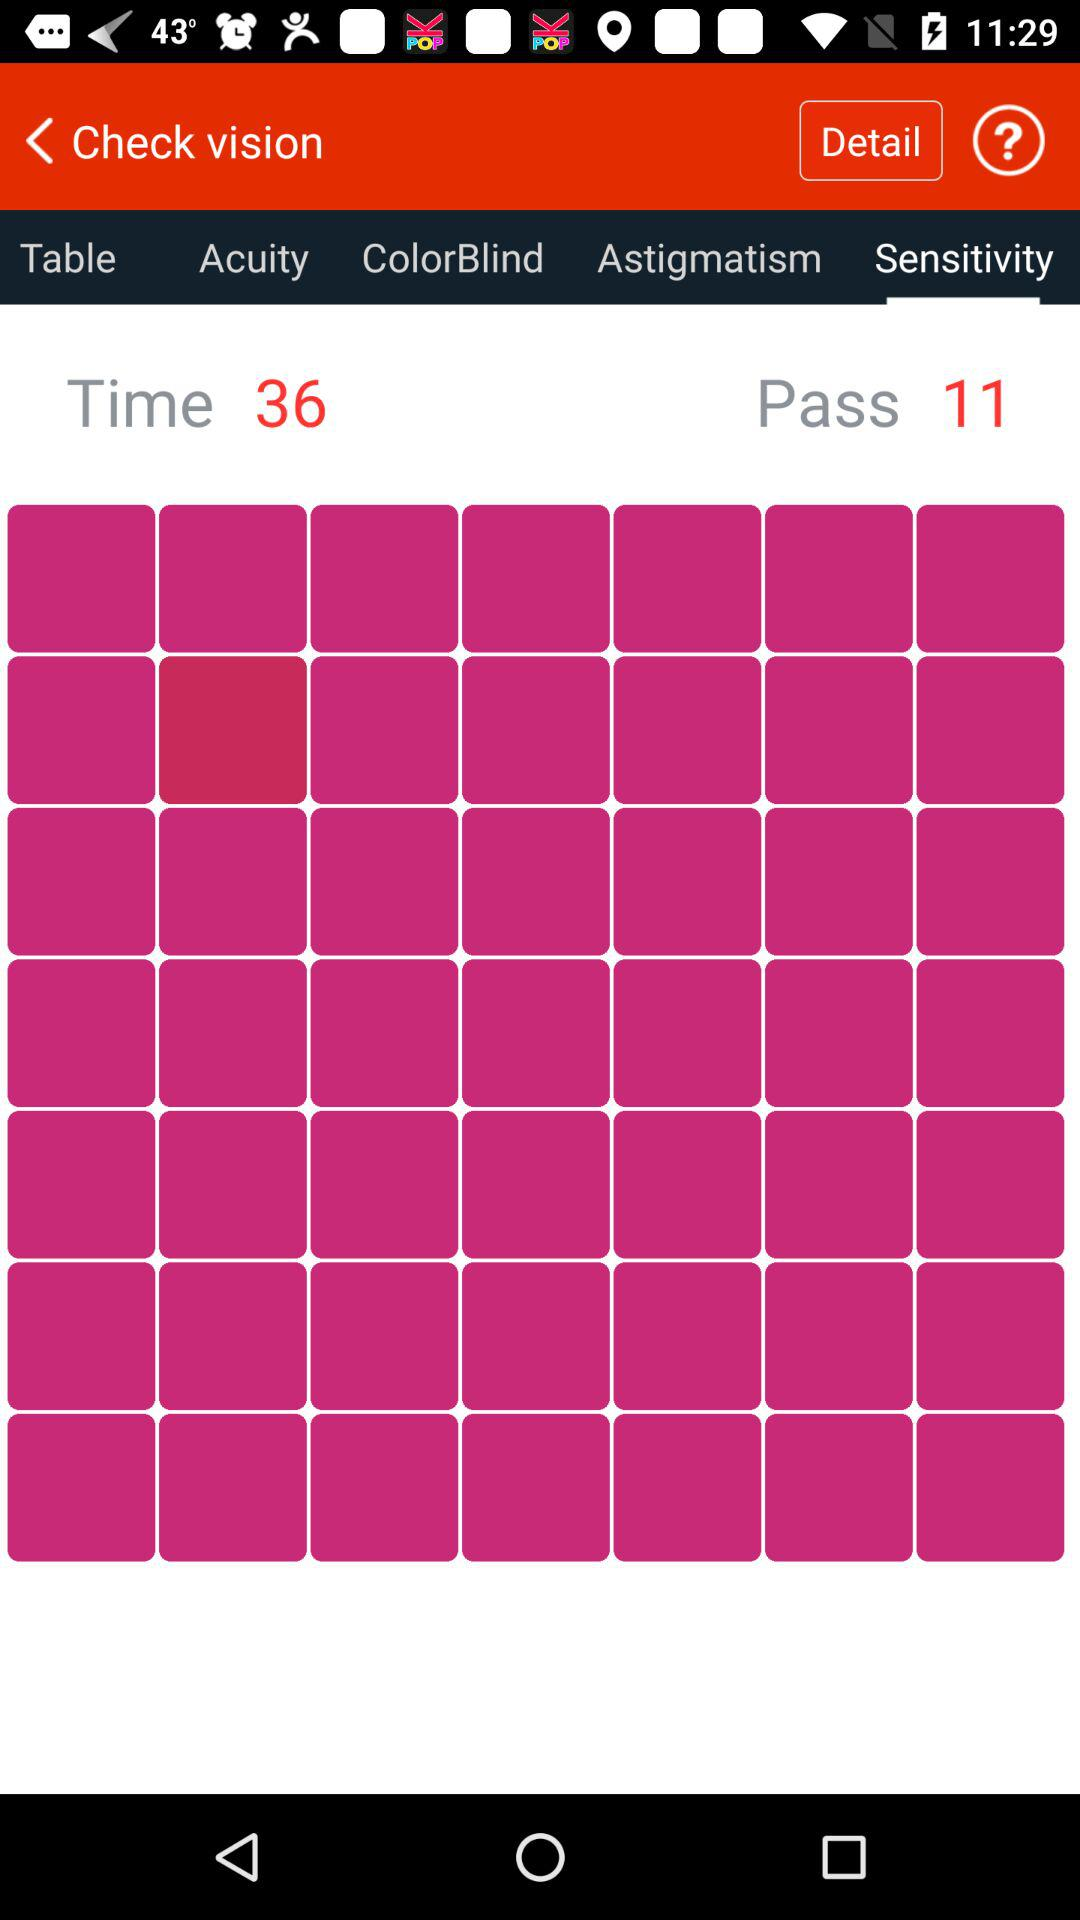What is the number in "Pass"? The number is 11. 